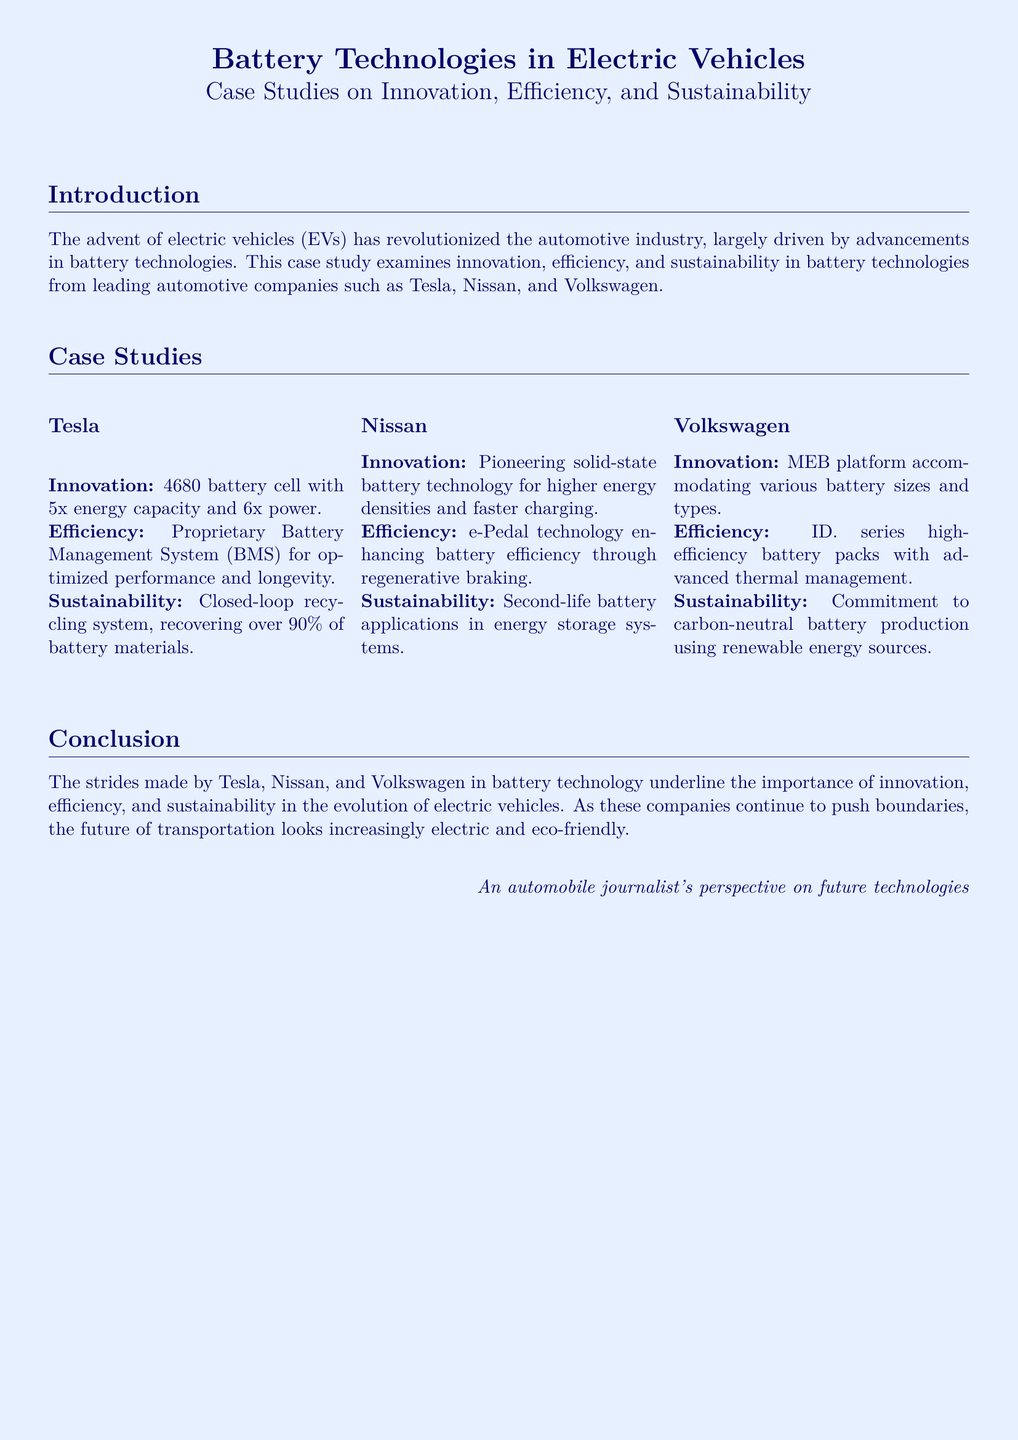What is the primary focus of the case study? The case study primarily focuses on advancements in battery technologies in electric vehicles, particularly relating to innovation, efficiency, and sustainability.
Answer: Battery technologies in electric vehicles What unique battery technology is Tesla utilizing? Tesla is utilizing the 4680 battery cell, which boasts significantly higher energy capacity and power output compared to previous batteries.
Answer: 4680 battery cell What is Nissan's notable innovation in battery technology? Nissan is pioneering solid-state battery technology, which emphasizes higher energy densities and faster charging capabilities.
Answer: Solid-state battery technology What percentage of battery materials does Tesla's recycling system recover? The document mentions that Tesla's closed-loop recycling system is capable of recovering over 90% of battery materials.
Answer: Over 90% Which platform does Volkswagen use to accommodate various battery sizes? Volkswagen uses the MEB platform, which is specifically designed to accept different battery sizes and types in its vehicles.
Answer: MEB platform How does Nissan enhance battery efficiency? Nissan enhances battery efficiency through the implementation of e-Pedal technology, which utilizes regenerative braking.
Answer: e-Pedal technology What is Volkswagen's commitment regarding battery production? Volkswagen is committed to achieving carbon-neutral battery production, which involves using renewable energy sources for manufacturing.
Answer: Carbon-neutral battery production What are the three key themes examined in the case study? The case study explores the themes of innovation, efficiency, and sustainability as they relate to battery technologies.
Answer: Innovation, efficiency, sustainability 